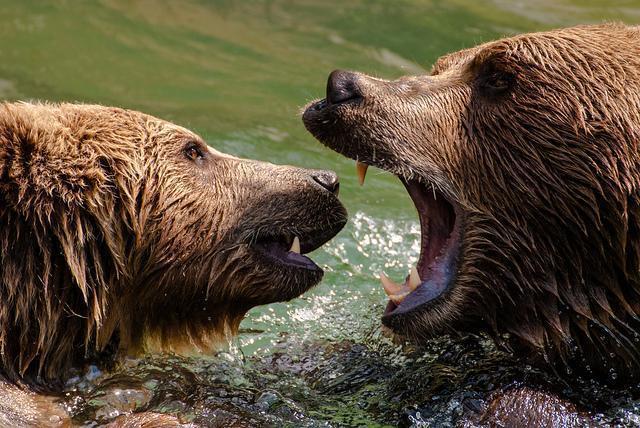How many bears are there?
Give a very brief answer. 2. 